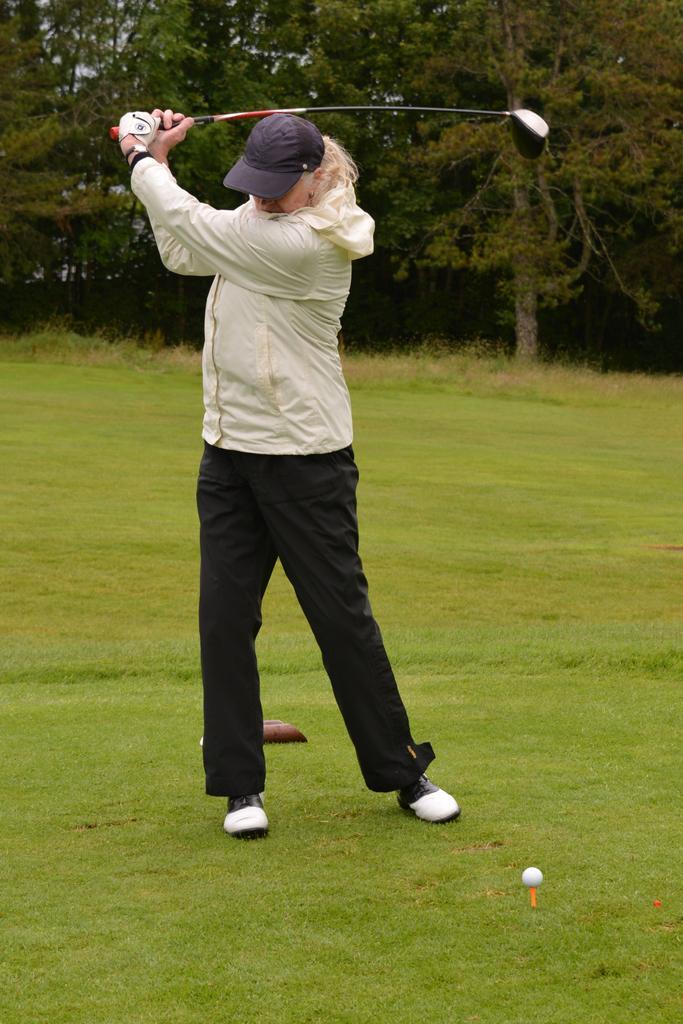Describe this image in one or two sentences. This is a playing ground. At the bottom, I can see the grass. In the middle of the image there is a woman wearing a jacket, cap on the head, standing, holding a bat in the hands and playing golf. On the right side there is a ball on the ground. In a background there are many trees. 